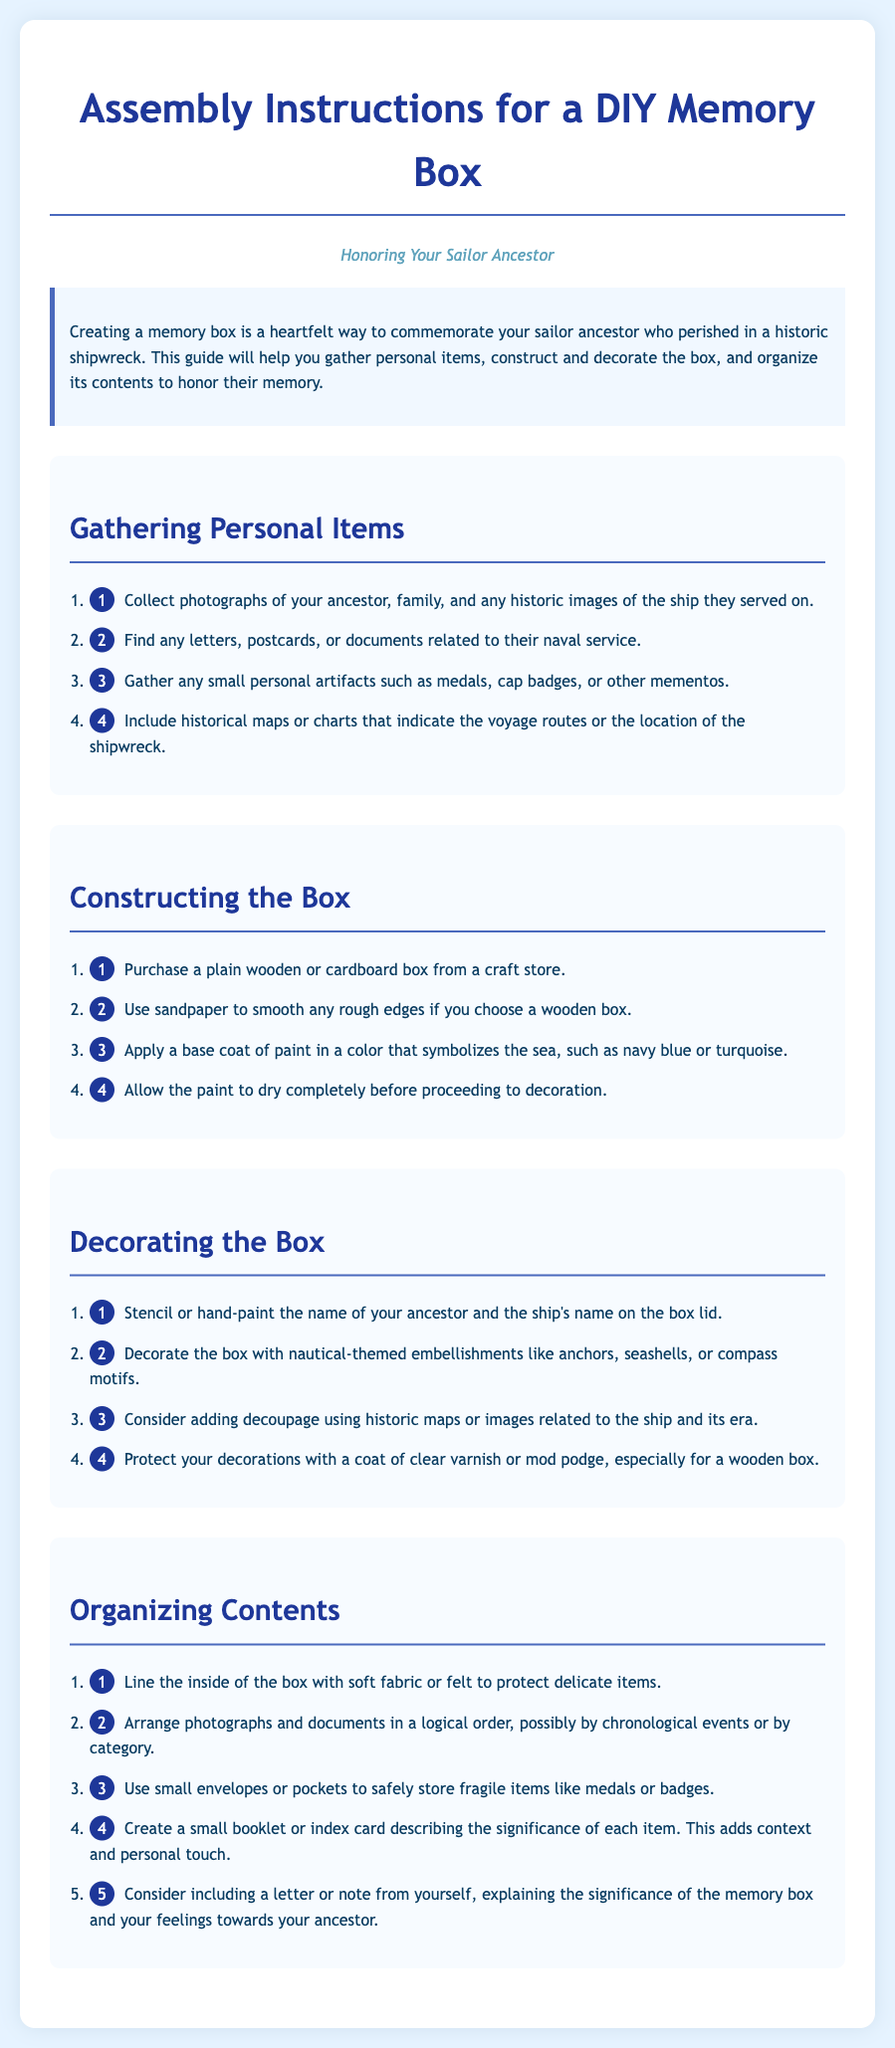what is the title of the document? The title of the document is presented at the top and identifies the purpose of the guide.
Answer: DIY Memory Box: Honoring Your Sailor Ancestor how many steps are in the "Gathering Personal Items" section? The section lists a total of four steps for gathering items.
Answer: 4 what color is suggested for the box's base coat? The document recommends a color that symbolizes the sea, mentioning specific colors.
Answer: navy blue or turquoise what is the purpose of lining the box with fabric or felt? The reasoning behind this step is to protect delicate items placed inside the box.
Answer: protect delicate items which embellishments are suggested for decorating? The document mentions specific themes to use for enhancing the appearance of the box.
Answer: anchors, seashells, or compass motifs how many items should be explained in the small booklet or index card? The document suggests creating a description for each significant item in the box.
Answer: each item what is a recommended addition to the memory box? This adds a personal touch and context about the items inside the box.
Answer: a letter or note from yourself 